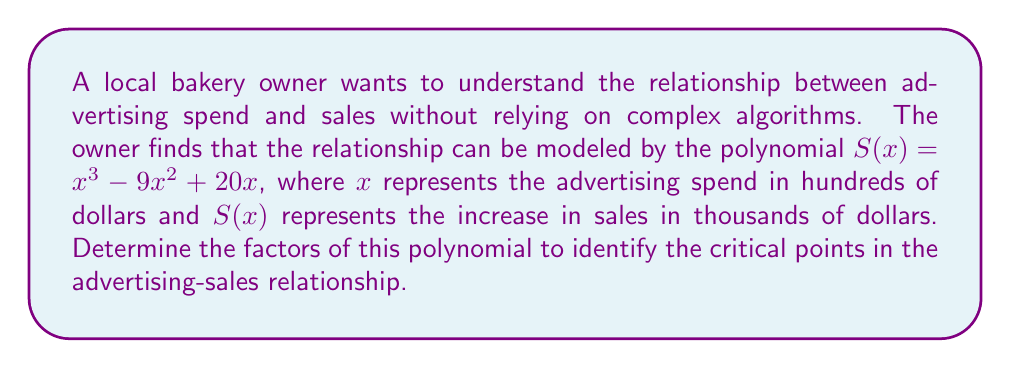Provide a solution to this math problem. Let's factor the polynomial $S(x) = x^3 - 9x^2 + 20x$ step by step:

1) First, we can factor out the greatest common factor (GCF):
   $S(x) = x(x^2 - 9x + 20)$

2) Now we focus on the quadratic factor $x^2 - 9x + 20$:
   
   a) The product of the roots should be 20
   b) The sum of the roots should be 9 (the negative of the coefficient of x)

3) We're looking for two numbers that multiply to give 20 and add up to 9. These numbers are 4 and 5.

4) We can rewrite the quadratic as:
   $x^2 - 9x + 20 = (x - 4)(x - 5)$

5) Combining this with our earlier factoring, we get:
   $S(x) = x(x - 4)(x - 5)$

This factorization shows that the sales increase will be zero when:
- $x = 0$ (no advertising spend)
- $x = 4$ ($400 in advertising spend)
- $x = 5$ ($500 in advertising spend)

These points represent critical thresholds in the advertising-sales relationship, which can guide the bakery owner's traditional marketing strategy without relying on complex algorithms.
Answer: $S(x) = x(x - 4)(x - 5)$ 